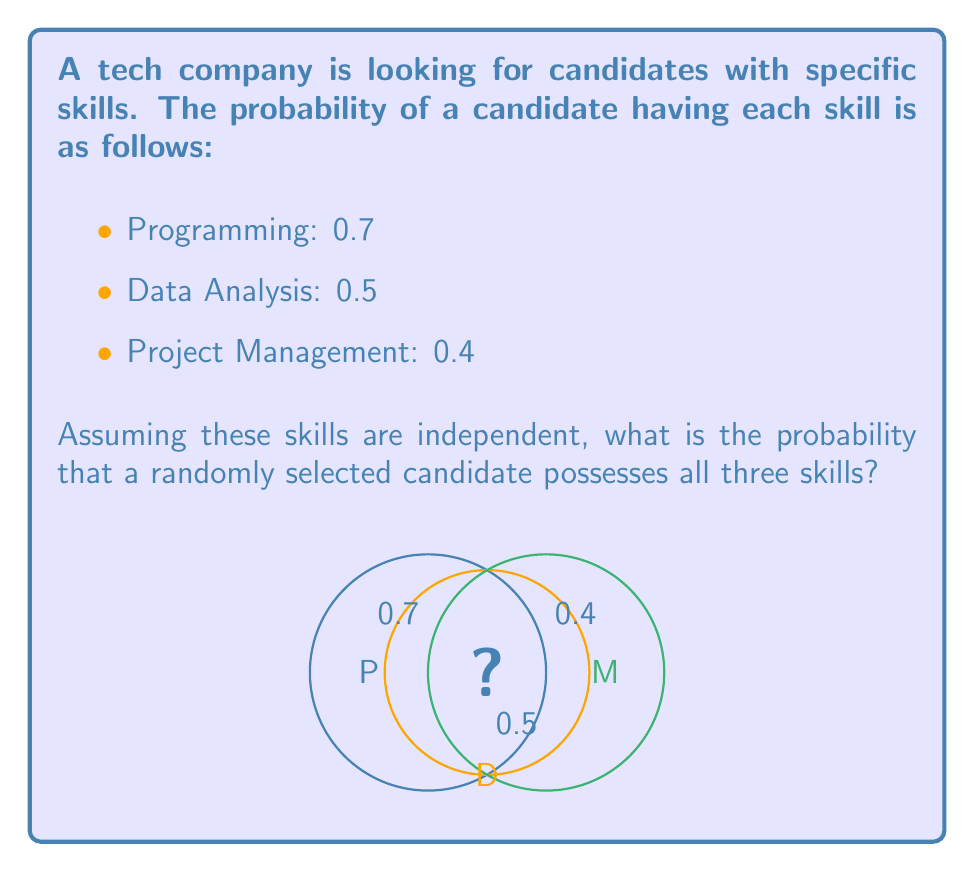Teach me how to tackle this problem. To solve this problem, we'll use the multiplication rule for independent events. Since the skills are assumed to be independent, we can multiply the individual probabilities to find the probability of all events occurring together.

Let's break it down step-by-step:

1) Let P(P) = Probability of having Programming skills = 0.7
   Let P(D) = Probability of having Data Analysis skills = 0.5
   Let P(M) = Probability of having Project Management skills = 0.4

2) We want to find P(P and D and M)

3) Since the events are independent:
   P(P and D and M) = P(P) × P(D) × P(M)

4) Substituting the values:
   P(P and D and M) = 0.7 × 0.5 × 0.4

5) Calculating:
   P(P and D and M) = 0.14

Therefore, the probability that a randomly selected candidate possesses all three skills is 0.14 or 14%.
Answer: $0.14$ 